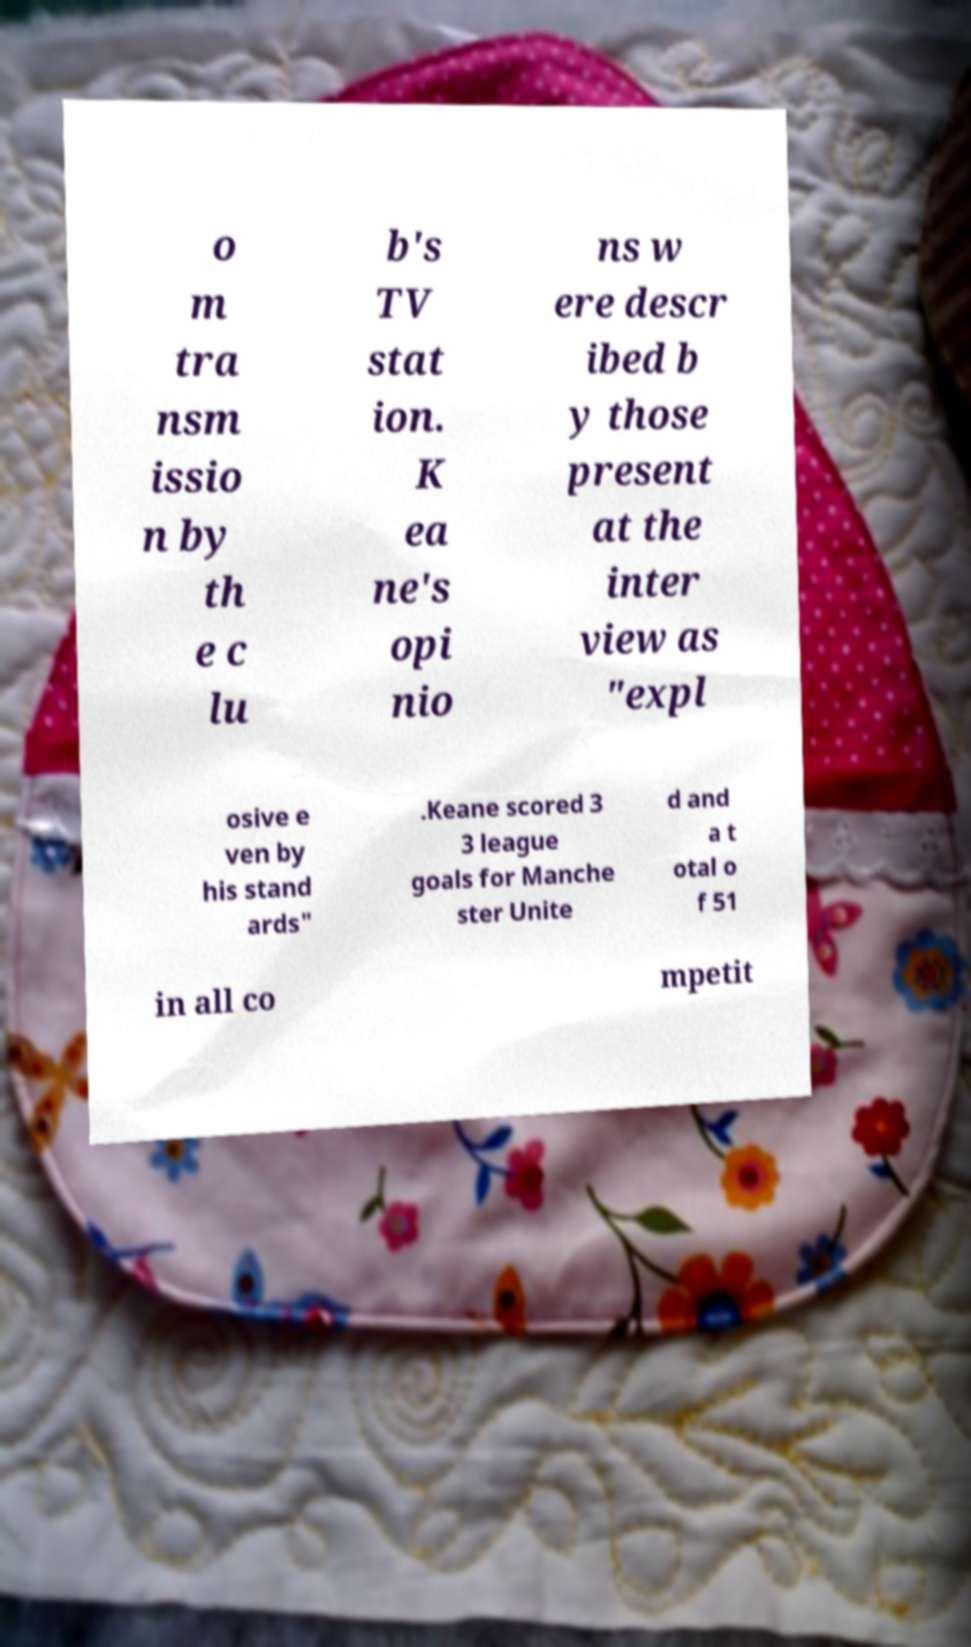I need the written content from this picture converted into text. Can you do that? o m tra nsm issio n by th e c lu b's TV stat ion. K ea ne's opi nio ns w ere descr ibed b y those present at the inter view as "expl osive e ven by his stand ards" .Keane scored 3 3 league goals for Manche ster Unite d and a t otal o f 51 in all co mpetit 